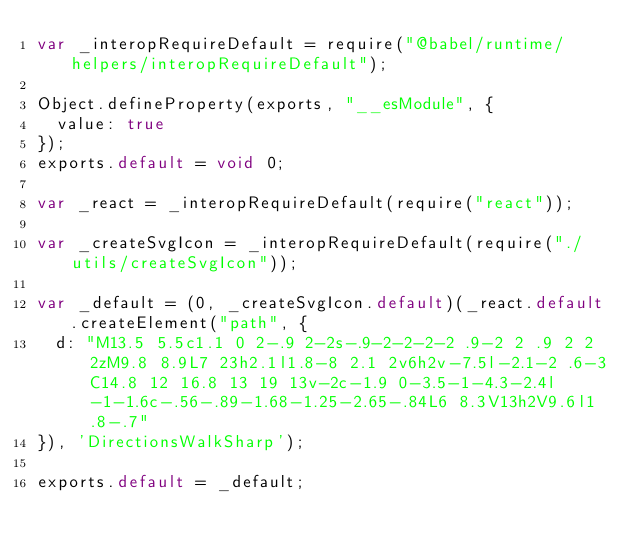<code> <loc_0><loc_0><loc_500><loc_500><_JavaScript_>var _interopRequireDefault = require("@babel/runtime/helpers/interopRequireDefault");

Object.defineProperty(exports, "__esModule", {
  value: true
});
exports.default = void 0;

var _react = _interopRequireDefault(require("react"));

var _createSvgIcon = _interopRequireDefault(require("./utils/createSvgIcon"));

var _default = (0, _createSvgIcon.default)(_react.default.createElement("path", {
  d: "M13.5 5.5c1.1 0 2-.9 2-2s-.9-2-2-2-2 .9-2 2 .9 2 2 2zM9.8 8.9L7 23h2.1l1.8-8 2.1 2v6h2v-7.5l-2.1-2 .6-3C14.8 12 16.8 13 19 13v-2c-1.9 0-3.5-1-4.3-2.4l-1-1.6c-.56-.89-1.68-1.25-2.65-.84L6 8.3V13h2V9.6l1.8-.7"
}), 'DirectionsWalkSharp');

exports.default = _default;</code> 